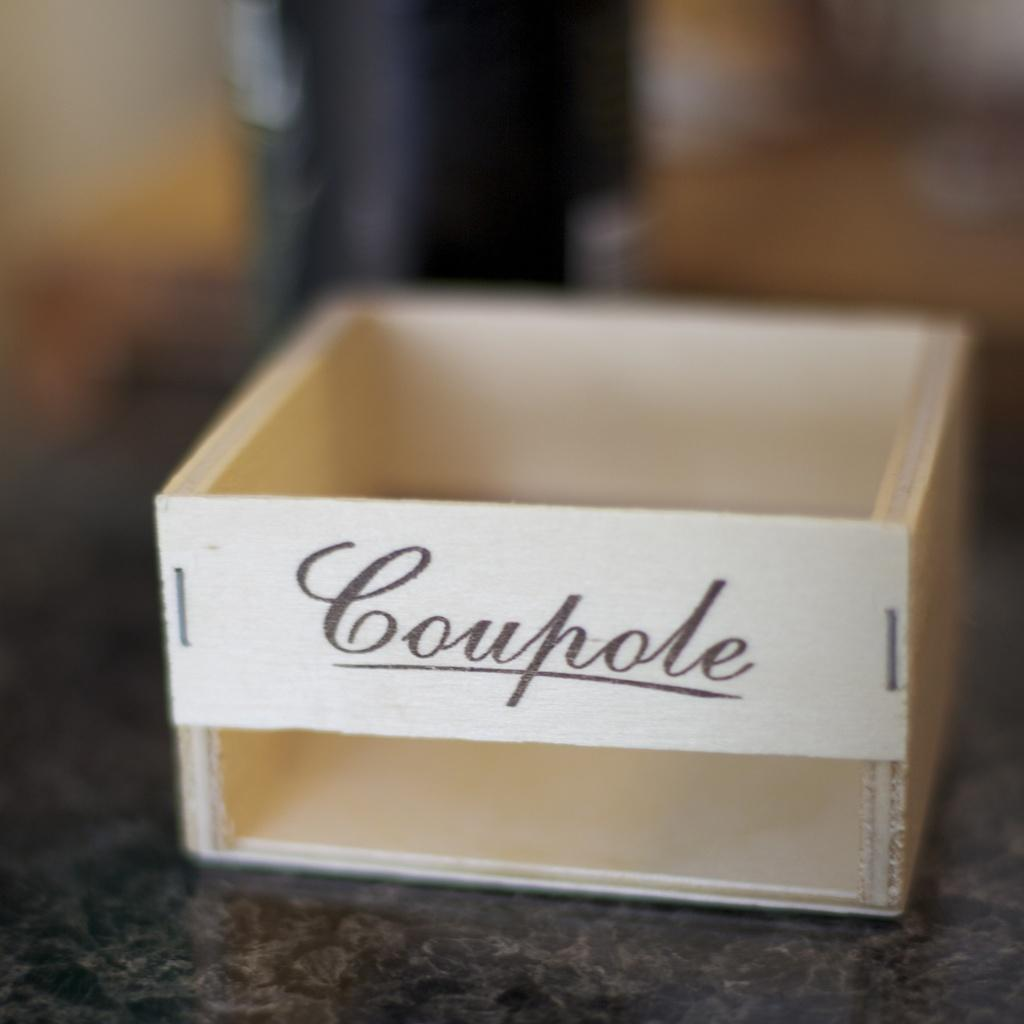<image>
Present a compact description of the photo's key features. wooden box with coupole stapled to front on a granite counter top 